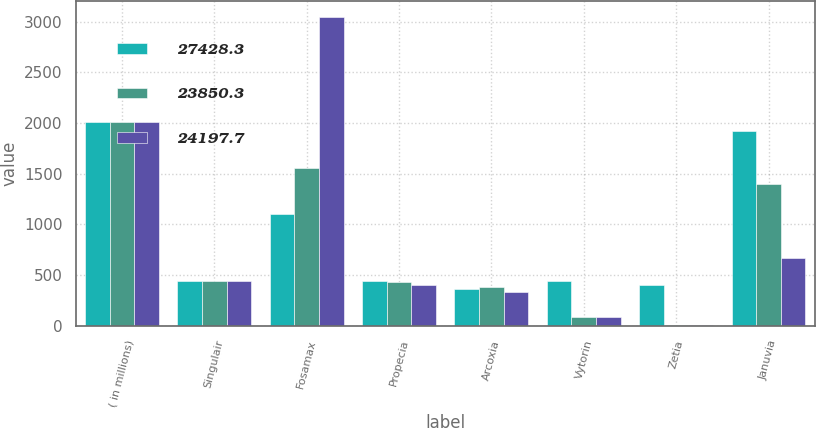<chart> <loc_0><loc_0><loc_500><loc_500><stacked_bar_chart><ecel><fcel>( in millions)<fcel>Singulair<fcel>Fosamax<fcel>Propecia<fcel>Arcoxia<fcel>Vytorin<fcel>Zetia<fcel>Januvia<nl><fcel>27428.3<fcel>2009<fcel>440.3<fcel>1099.8<fcel>440.3<fcel>357.5<fcel>440.8<fcel>402.9<fcel>1922.1<nl><fcel>23850.3<fcel>2008<fcel>440.3<fcel>1552.7<fcel>429.1<fcel>377.3<fcel>84.2<fcel>6.4<fcel>1397.1<nl><fcel>24197.7<fcel>2007<fcel>440.3<fcel>3049<fcel>405.4<fcel>329.1<fcel>84.3<fcel>6.5<fcel>667.5<nl></chart> 